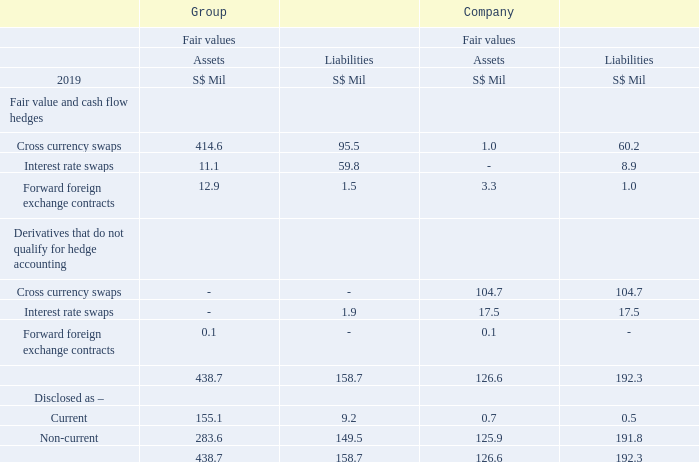18.1 Fair Values
The fair values of the currency and interest rate swap contracts exclude accrued interest of S$16.3 million (31 March 2018: S$16.8 million). The accrued interest is separately disclosed in Note 16 and Note 27.
The fair values of the derivative financial instruments were as follows –
What does the information in note 18.1 pertain to? Fair values. What does the fair value of the currency and interest rate swap contracts not include? Accrued interest. Where to find the disclosed information on accrued interest? Note 16 and note 27. How many different types of derivative financial instruments are there in the fair value and cash flow hedges? Cross currency swaps##Interest rate swaps##Forward foreign exchange contracts
Answer: 3. What is the % of the total group current financial assets that is attributable to the company? 
Answer scale should be: percent. 0.7/155.1
Answer: 0.45. How many % of the company's derivative financial liabilities are being disclosed as non-current?
Answer scale should be: percent. 191.8/192.3
Answer: 99.74. 